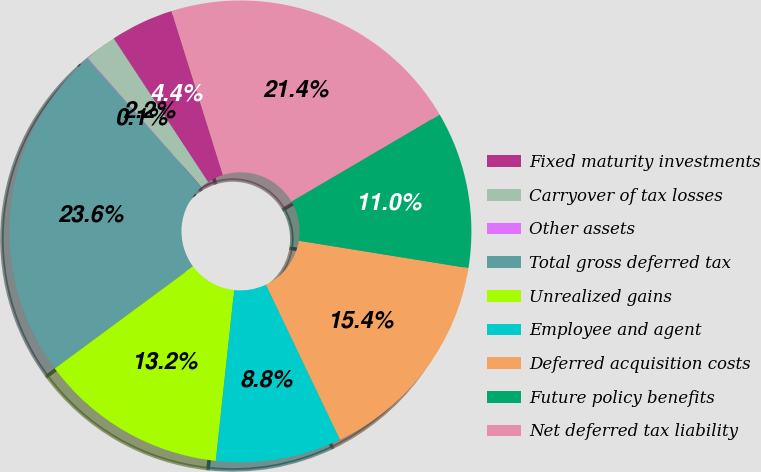Convert chart to OTSL. <chart><loc_0><loc_0><loc_500><loc_500><pie_chart><fcel>Fixed maturity investments<fcel>Carryover of tax losses<fcel>Other assets<fcel>Total gross deferred tax<fcel>Unrealized gains<fcel>Employee and agent<fcel>Deferred acquisition costs<fcel>Future policy benefits<fcel>Net deferred tax liability<nl><fcel>4.43%<fcel>2.24%<fcel>0.05%<fcel>23.57%<fcel>13.17%<fcel>8.8%<fcel>15.36%<fcel>10.99%<fcel>21.38%<nl></chart> 